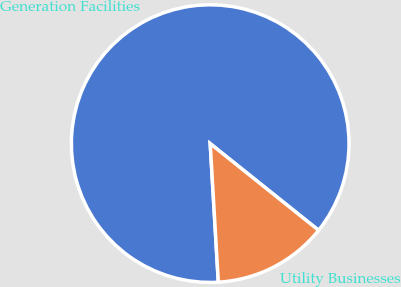Convert chart to OTSL. <chart><loc_0><loc_0><loc_500><loc_500><pie_chart><fcel>Generation Facilities<fcel>Utility Businesses<nl><fcel>86.67%<fcel>13.33%<nl></chart> 